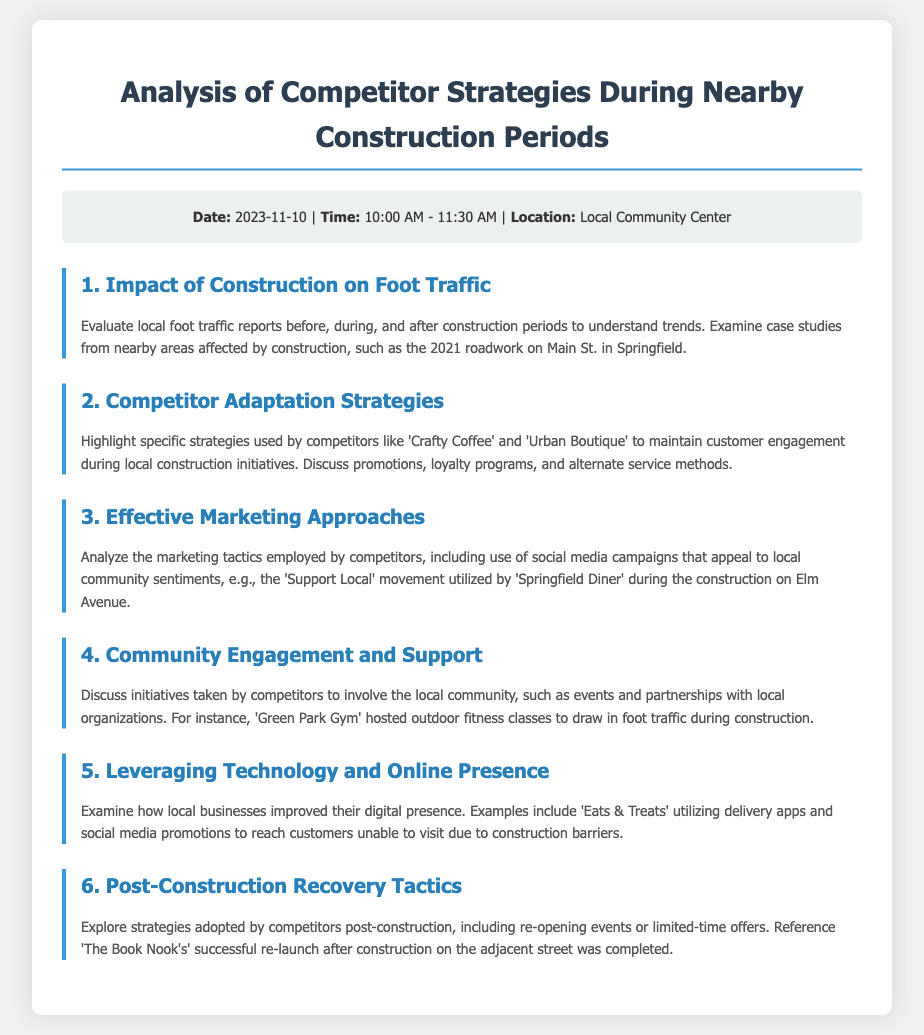what is the date of the meeting? The document specifies that the meeting is scheduled for 2023-11-10.
Answer: 2023-11-10 what time does the meeting start? The agenda states that the meeting will start at 10:00 AM.
Answer: 10:00 AM which location is mentioned for the meeting? According to the document, the meeting will take place at the Local Community Center.
Answer: Local Community Center what is the first agenda item? The first agenda item listed is the Impact of Construction on Foot Traffic.
Answer: Impact of Construction on Foot Traffic which competitor is mentioned in the second agenda item? The second agenda item highlights the competitor 'Crafty Coffee'.
Answer: Crafty Coffee what marketing approach is discussed in the third agenda item? The marketing approach mentioned involves social media campaigns appealing to local community sentiments.
Answer: social media campaigns what specific event did 'Green Park Gym' host during construction? The document states that 'Green Park Gym' hosted outdoor fitness classes during construction.
Answer: outdoor fitness classes what example of post-construction recovery is referenced? The agenda references 'The Book Nook's' successful re-launch after construction.
Answer: The Book Nook how many agenda items are listed? There are a total of six agenda items mentioned in the document.
Answer: six 